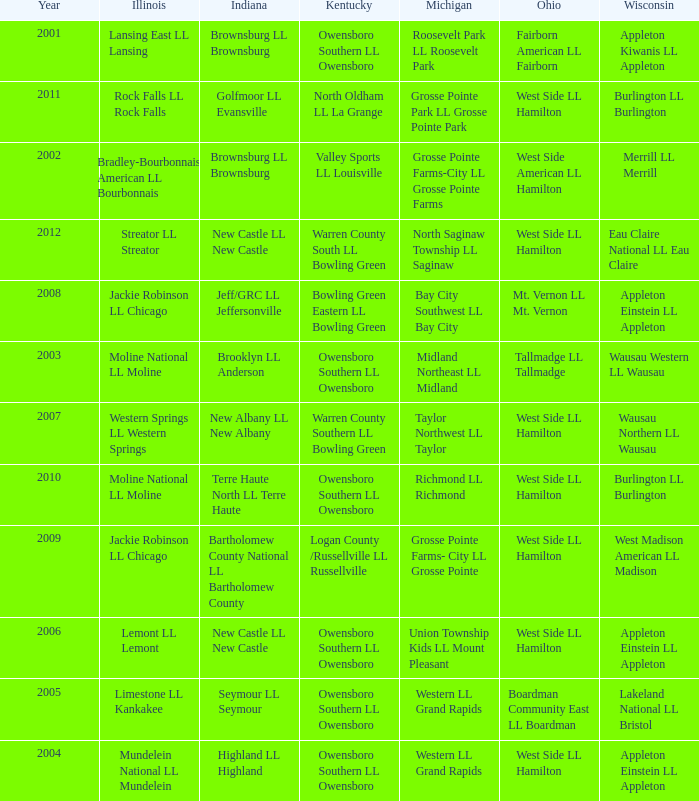What was the little league team from Michigan when the little league team from Indiana was Terre Haute North LL Terre Haute?  Richmond LL Richmond. 